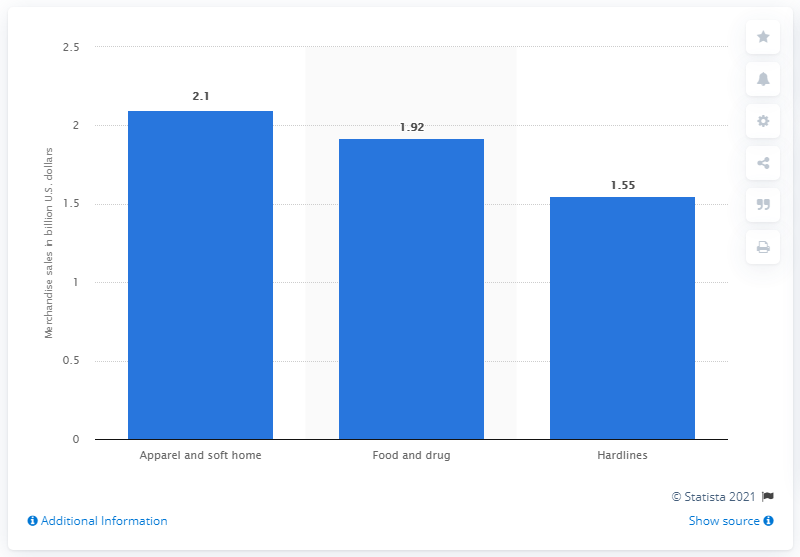Identify some key points in this picture. Kmart generated approximately 2.1 billion dollars in revenue from its apparel and soft home segment in 2017. 